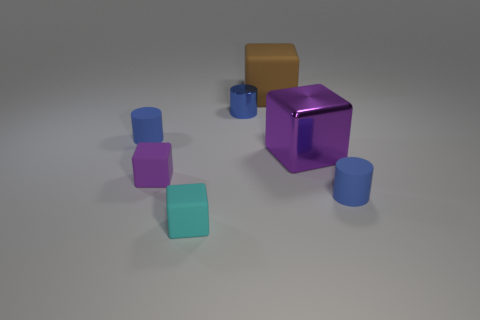Subtract all blue cylinders. How many were subtracted if there are1blue cylinders left? 2 Add 2 large cyan things. How many objects exist? 9 Subtract all brown blocks. How many blocks are left? 3 Subtract all blocks. How many objects are left? 3 Add 6 rubber blocks. How many rubber blocks are left? 9 Add 5 large blue blocks. How many large blue blocks exist? 5 Subtract all brown blocks. How many blocks are left? 3 Subtract 0 red cylinders. How many objects are left? 7 Subtract all green blocks. Subtract all cyan cylinders. How many blocks are left? 4 Subtract all purple balls. How many brown cylinders are left? 0 